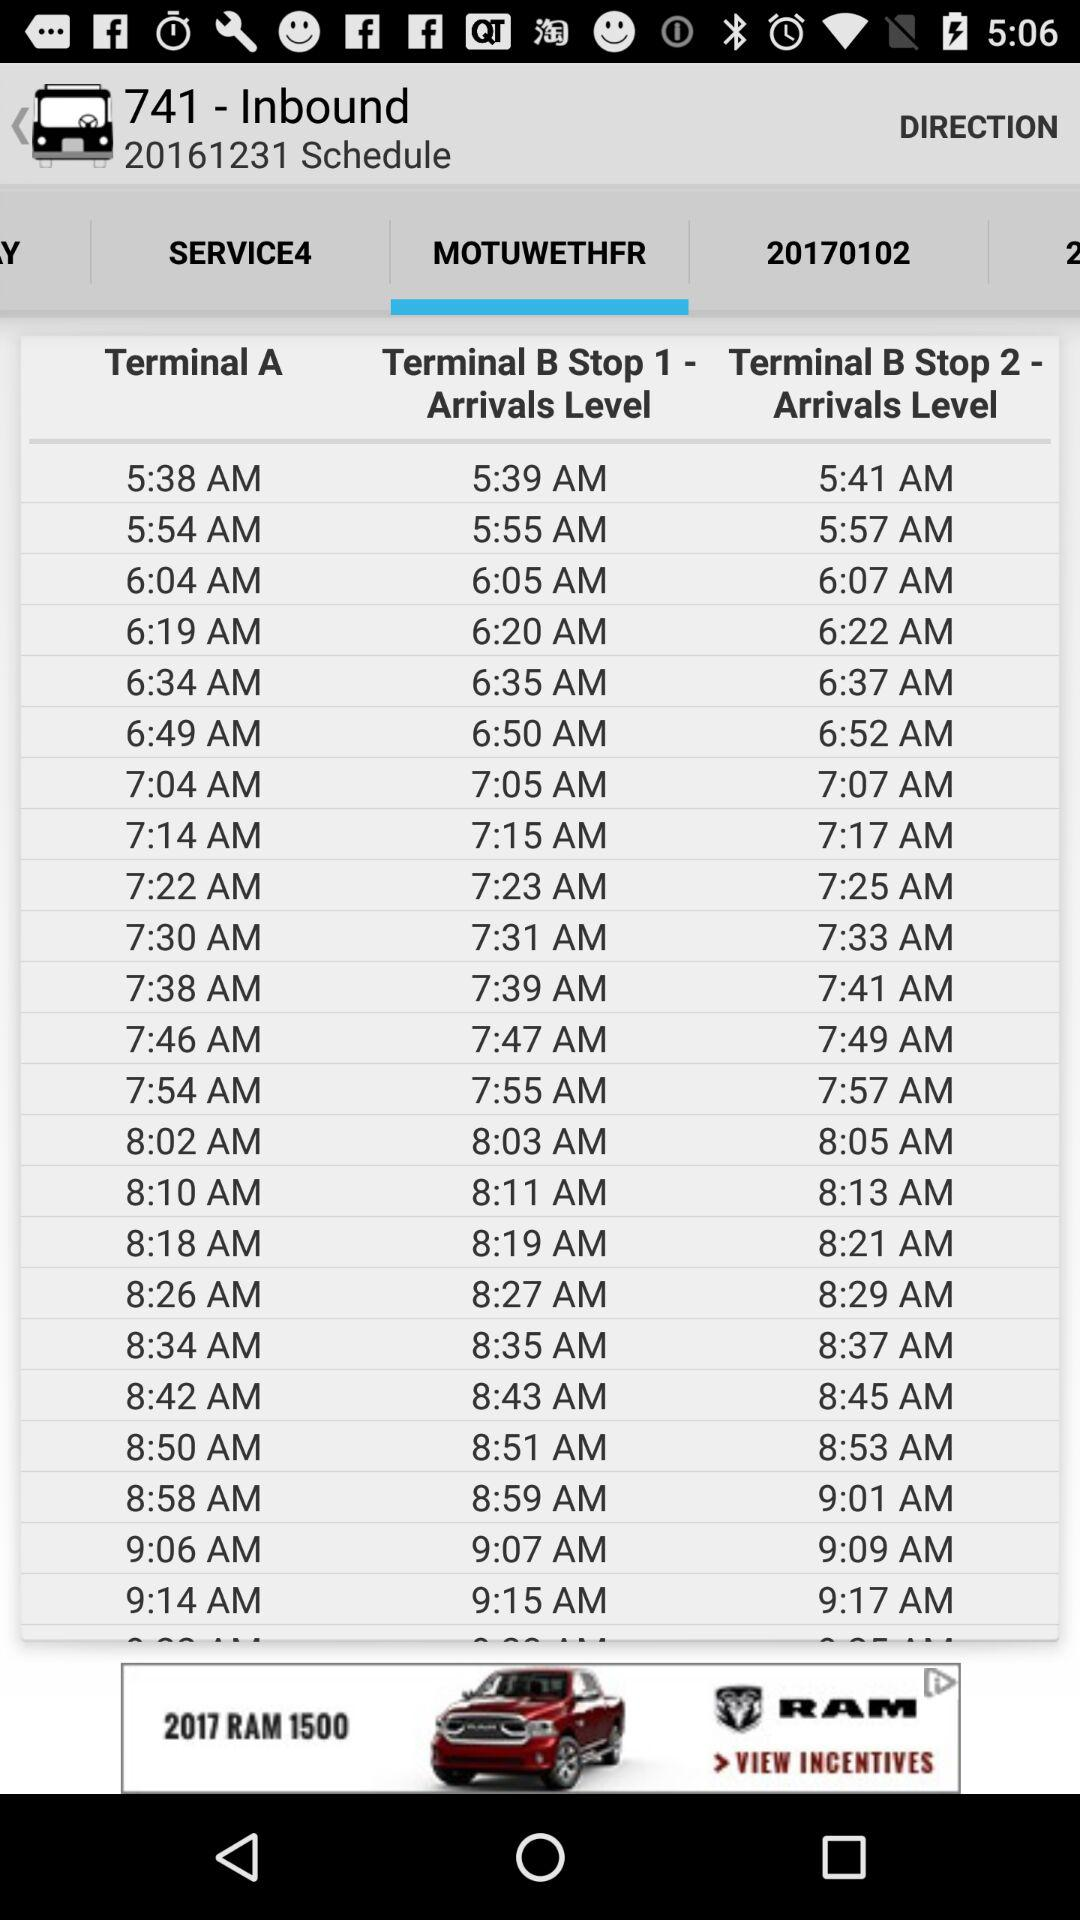What number is mentioned beside "Schedule"? The number mentioned beside "Schedule" is 20161231. 